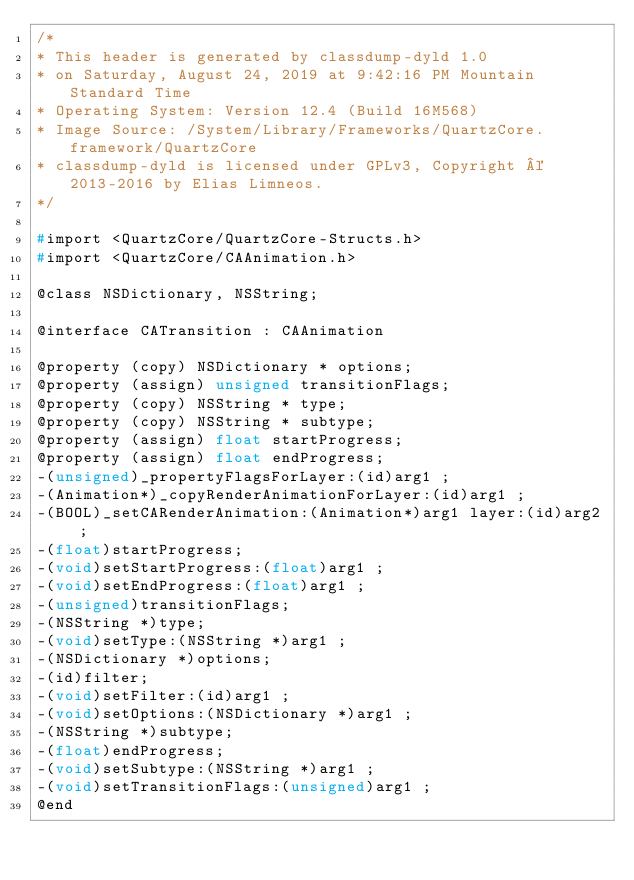Convert code to text. <code><loc_0><loc_0><loc_500><loc_500><_C_>/*
* This header is generated by classdump-dyld 1.0
* on Saturday, August 24, 2019 at 9:42:16 PM Mountain Standard Time
* Operating System: Version 12.4 (Build 16M568)
* Image Source: /System/Library/Frameworks/QuartzCore.framework/QuartzCore
* classdump-dyld is licensed under GPLv3, Copyright © 2013-2016 by Elias Limneos.
*/

#import <QuartzCore/QuartzCore-Structs.h>
#import <QuartzCore/CAAnimation.h>

@class NSDictionary, NSString;

@interface CATransition : CAAnimation

@property (copy) NSDictionary * options; 
@property (assign) unsigned transitionFlags; 
@property (copy) NSString * type; 
@property (copy) NSString * subtype; 
@property (assign) float startProgress; 
@property (assign) float endProgress; 
-(unsigned)_propertyFlagsForLayer:(id)arg1 ;
-(Animation*)_copyRenderAnimationForLayer:(id)arg1 ;
-(BOOL)_setCARenderAnimation:(Animation*)arg1 layer:(id)arg2 ;
-(float)startProgress;
-(void)setStartProgress:(float)arg1 ;
-(void)setEndProgress:(float)arg1 ;
-(unsigned)transitionFlags;
-(NSString *)type;
-(void)setType:(NSString *)arg1 ;
-(NSDictionary *)options;
-(id)filter;
-(void)setFilter:(id)arg1 ;
-(void)setOptions:(NSDictionary *)arg1 ;
-(NSString *)subtype;
-(float)endProgress;
-(void)setSubtype:(NSString *)arg1 ;
-(void)setTransitionFlags:(unsigned)arg1 ;
@end

</code> 